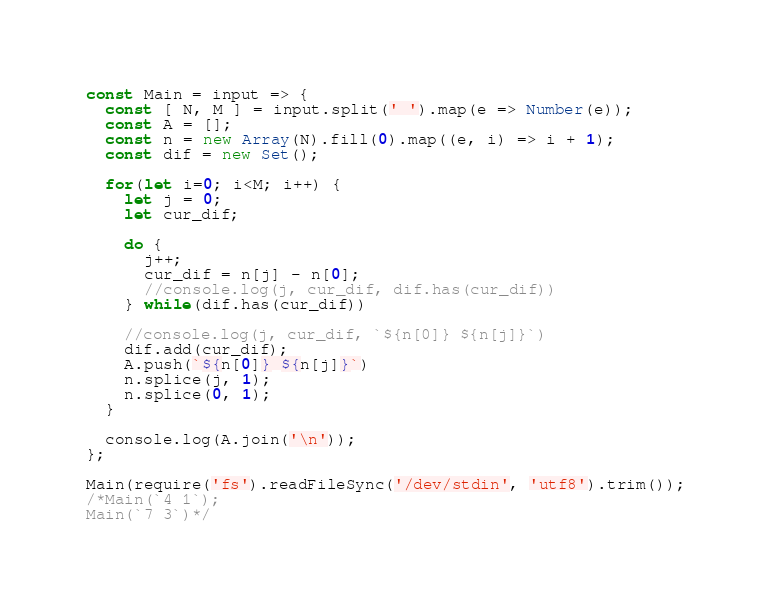<code> <loc_0><loc_0><loc_500><loc_500><_JavaScript_>const Main = input => {
  const [ N, M ] = input.split(' ').map(e => Number(e));
  const A = [];
  const n = new Array(N).fill(0).map((e, i) => i + 1);
  const dif = new Set();

  for(let i=0; i<M; i++) {
    let j = 0;
    let cur_dif;
    
    do {
      j++;
      cur_dif = n[j] - n[0];
      //console.log(j, cur_dif, dif.has(cur_dif))
    } while(dif.has(cur_dif))

    //console.log(j, cur_dif, `${n[0]} ${n[j]}`)
    dif.add(cur_dif);
    A.push(`${n[0]} ${n[j]}`)
    n.splice(j, 1);
    n.splice(0, 1);
  }

  console.log(A.join('\n'));
};

Main(require('fs').readFileSync('/dev/stdin', 'utf8').trim());
/*Main(`4 1`);
Main(`7 3`)*/
</code> 